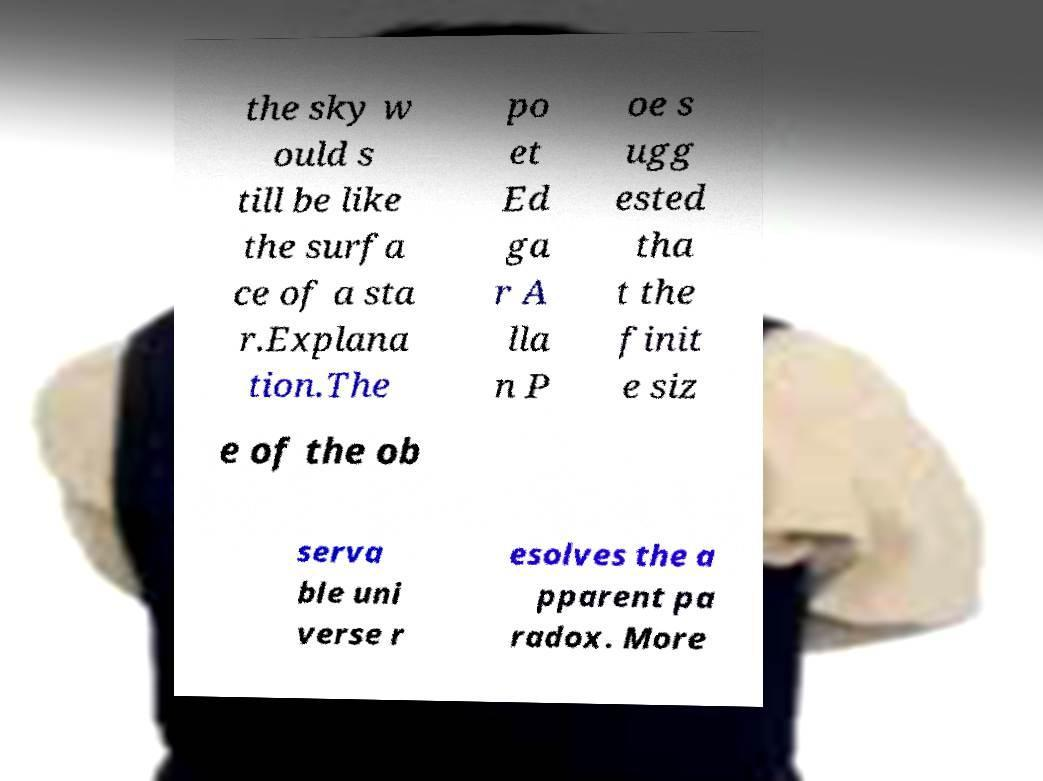Can you accurately transcribe the text from the provided image for me? the sky w ould s till be like the surfa ce of a sta r.Explana tion.The po et Ed ga r A lla n P oe s ugg ested tha t the finit e siz e of the ob serva ble uni verse r esolves the a pparent pa radox. More 